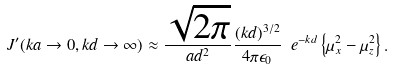<formula> <loc_0><loc_0><loc_500><loc_500>J ^ { \prime } ( k a \rightarrow 0 , k d \rightarrow \infty ) \approx \frac { \sqrt { 2 \pi } } { a d ^ { 2 } } \frac { ( k d ) ^ { 3 / 2 } } { 4 \pi \epsilon _ { 0 } } \ e ^ { - k d } \left \{ \mu _ { x } ^ { 2 } - \mu _ { z } ^ { 2 } \right \} .</formula> 